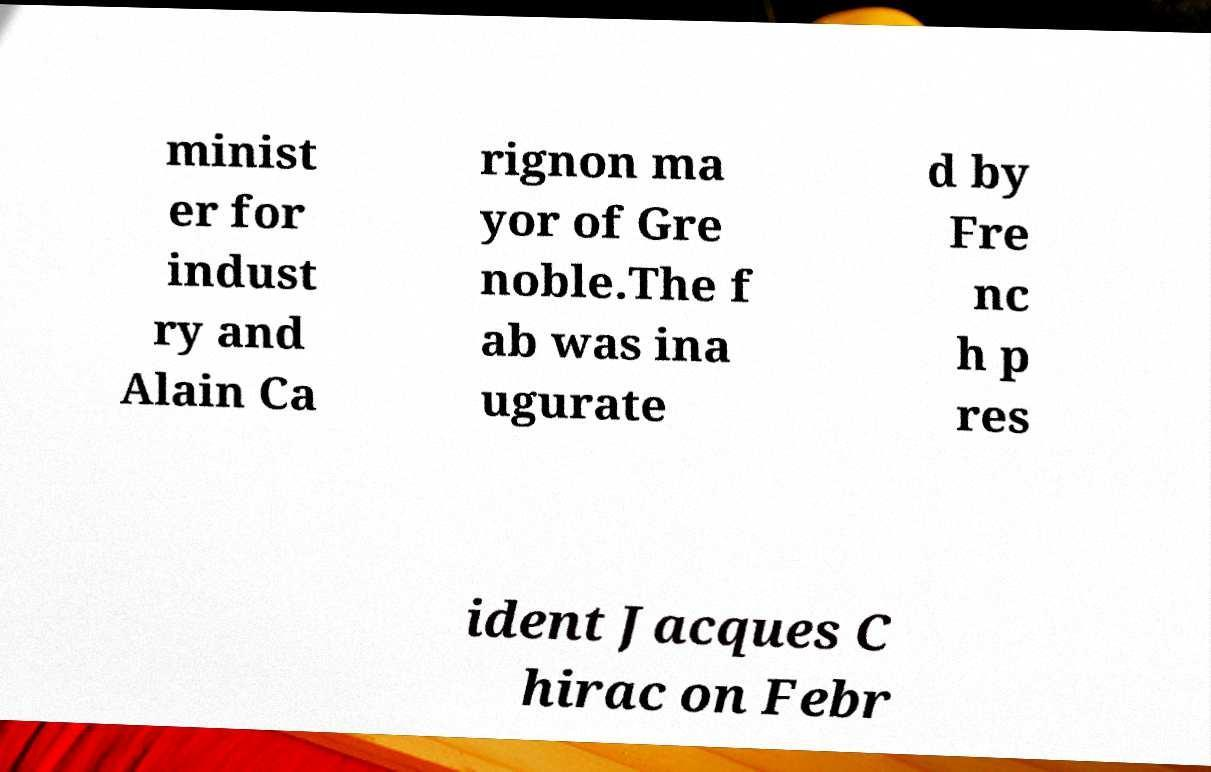Can you read and provide the text displayed in the image?This photo seems to have some interesting text. Can you extract and type it out for me? minist er for indust ry and Alain Ca rignon ma yor of Gre noble.The f ab was ina ugurate d by Fre nc h p res ident Jacques C hirac on Febr 